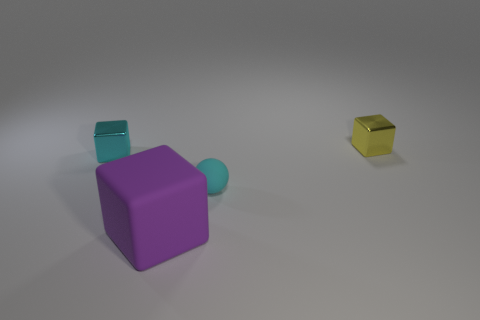Are there fewer rubber things in front of the small cyan rubber sphere than large gray rubber cylinders?
Make the answer very short. No. Are there any big purple things to the left of the metal block on the left side of the small shiny cube that is behind the cyan metallic block?
Ensure brevity in your answer.  No. Is the tiny cyan block made of the same material as the small block that is on the right side of the big matte thing?
Offer a terse response. Yes. There is a thing on the right side of the small cyan thing right of the large object; what is its color?
Ensure brevity in your answer.  Yellow. Are there any small cubes of the same color as the sphere?
Ensure brevity in your answer.  Yes. What size is the block in front of the cyan thing that is to the left of the matte thing that is behind the purple block?
Provide a short and direct response. Large. Is the shape of the cyan metallic object the same as the rubber object to the right of the big purple thing?
Give a very brief answer. No. How many other things are the same size as the rubber ball?
Your answer should be very brief. 2. There is a metallic object right of the large object; what size is it?
Your answer should be compact. Small. How many purple objects have the same material as the small ball?
Provide a succinct answer. 1. 